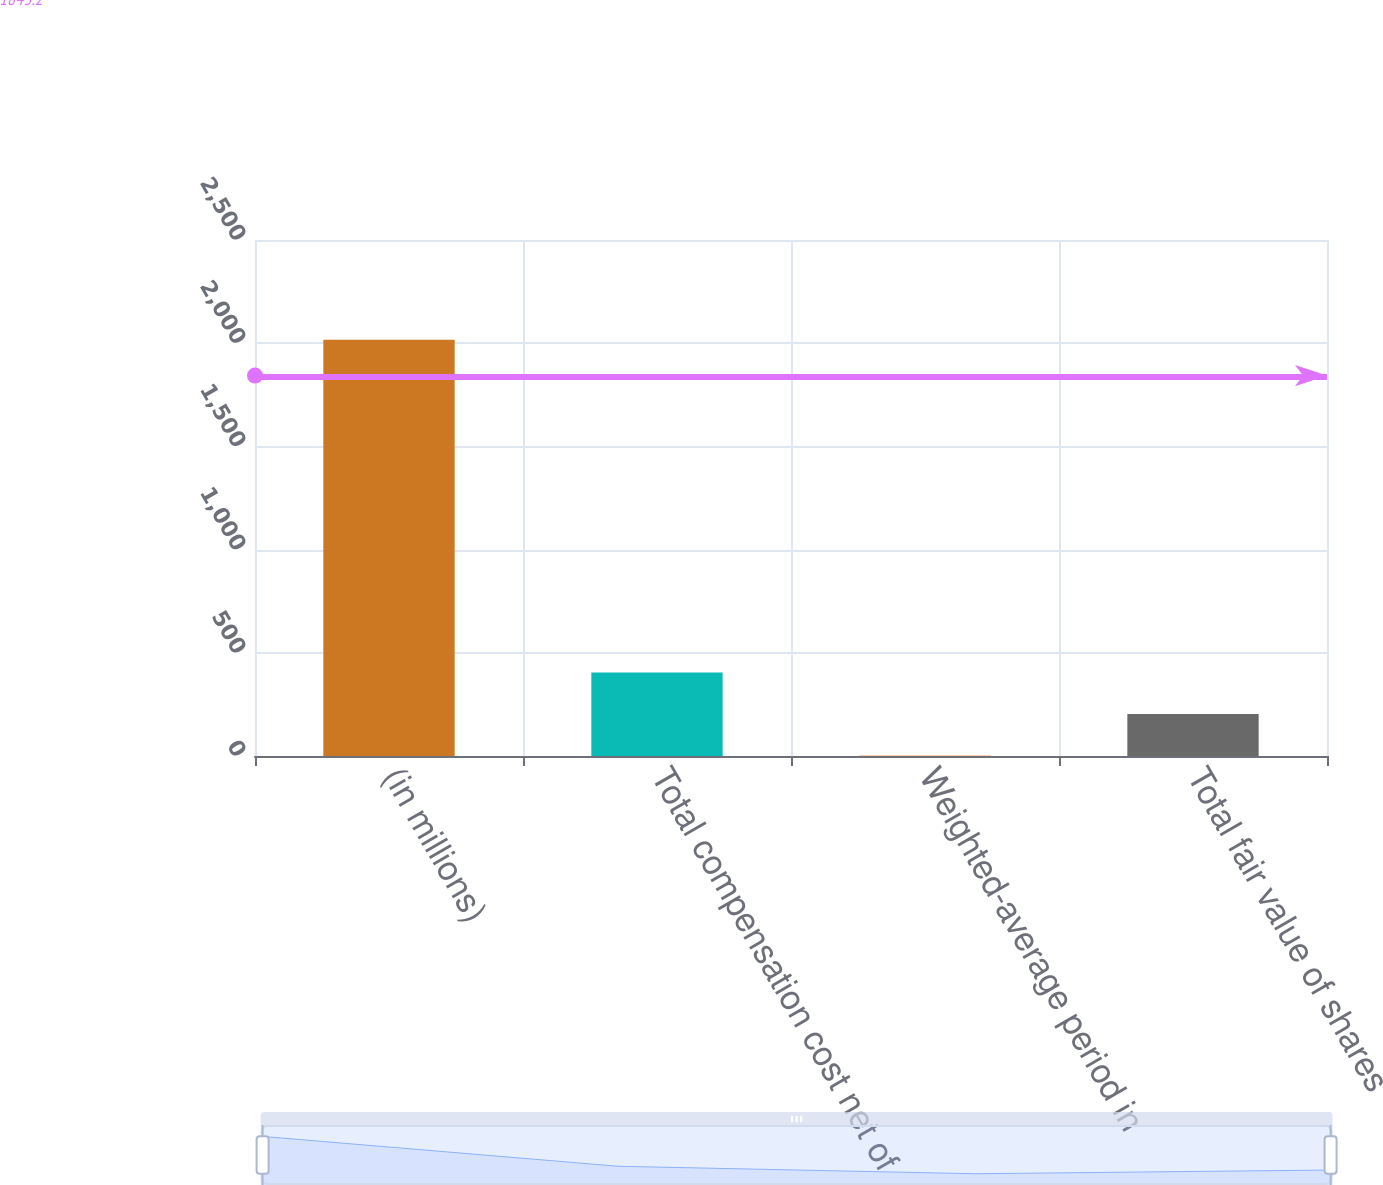Convert chart to OTSL. <chart><loc_0><loc_0><loc_500><loc_500><bar_chart><fcel>(in millions)<fcel>Total compensation cost net of<fcel>Weighted-average period in<fcel>Total fair value of shares<nl><fcel>2017<fcel>405<fcel>2<fcel>203.5<nl></chart> 